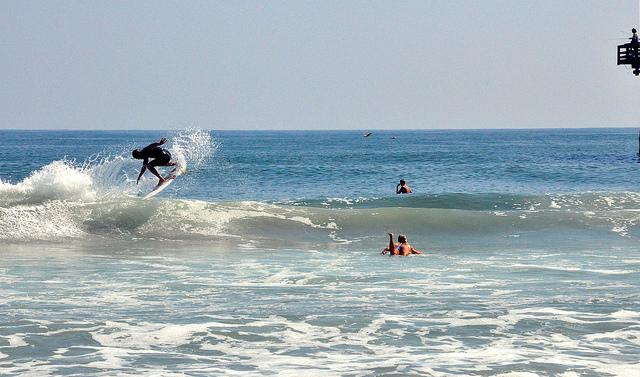How many people are in the water?
Write a very short answer. 3. What are these people holding?
Keep it brief. Surfboards. How many objects are in this picture?
Give a very brief answer. 3. What are the people doing on the beach?
Short answer required. Surfing. Is the surfer good at the sport?
Keep it brief. Yes. 